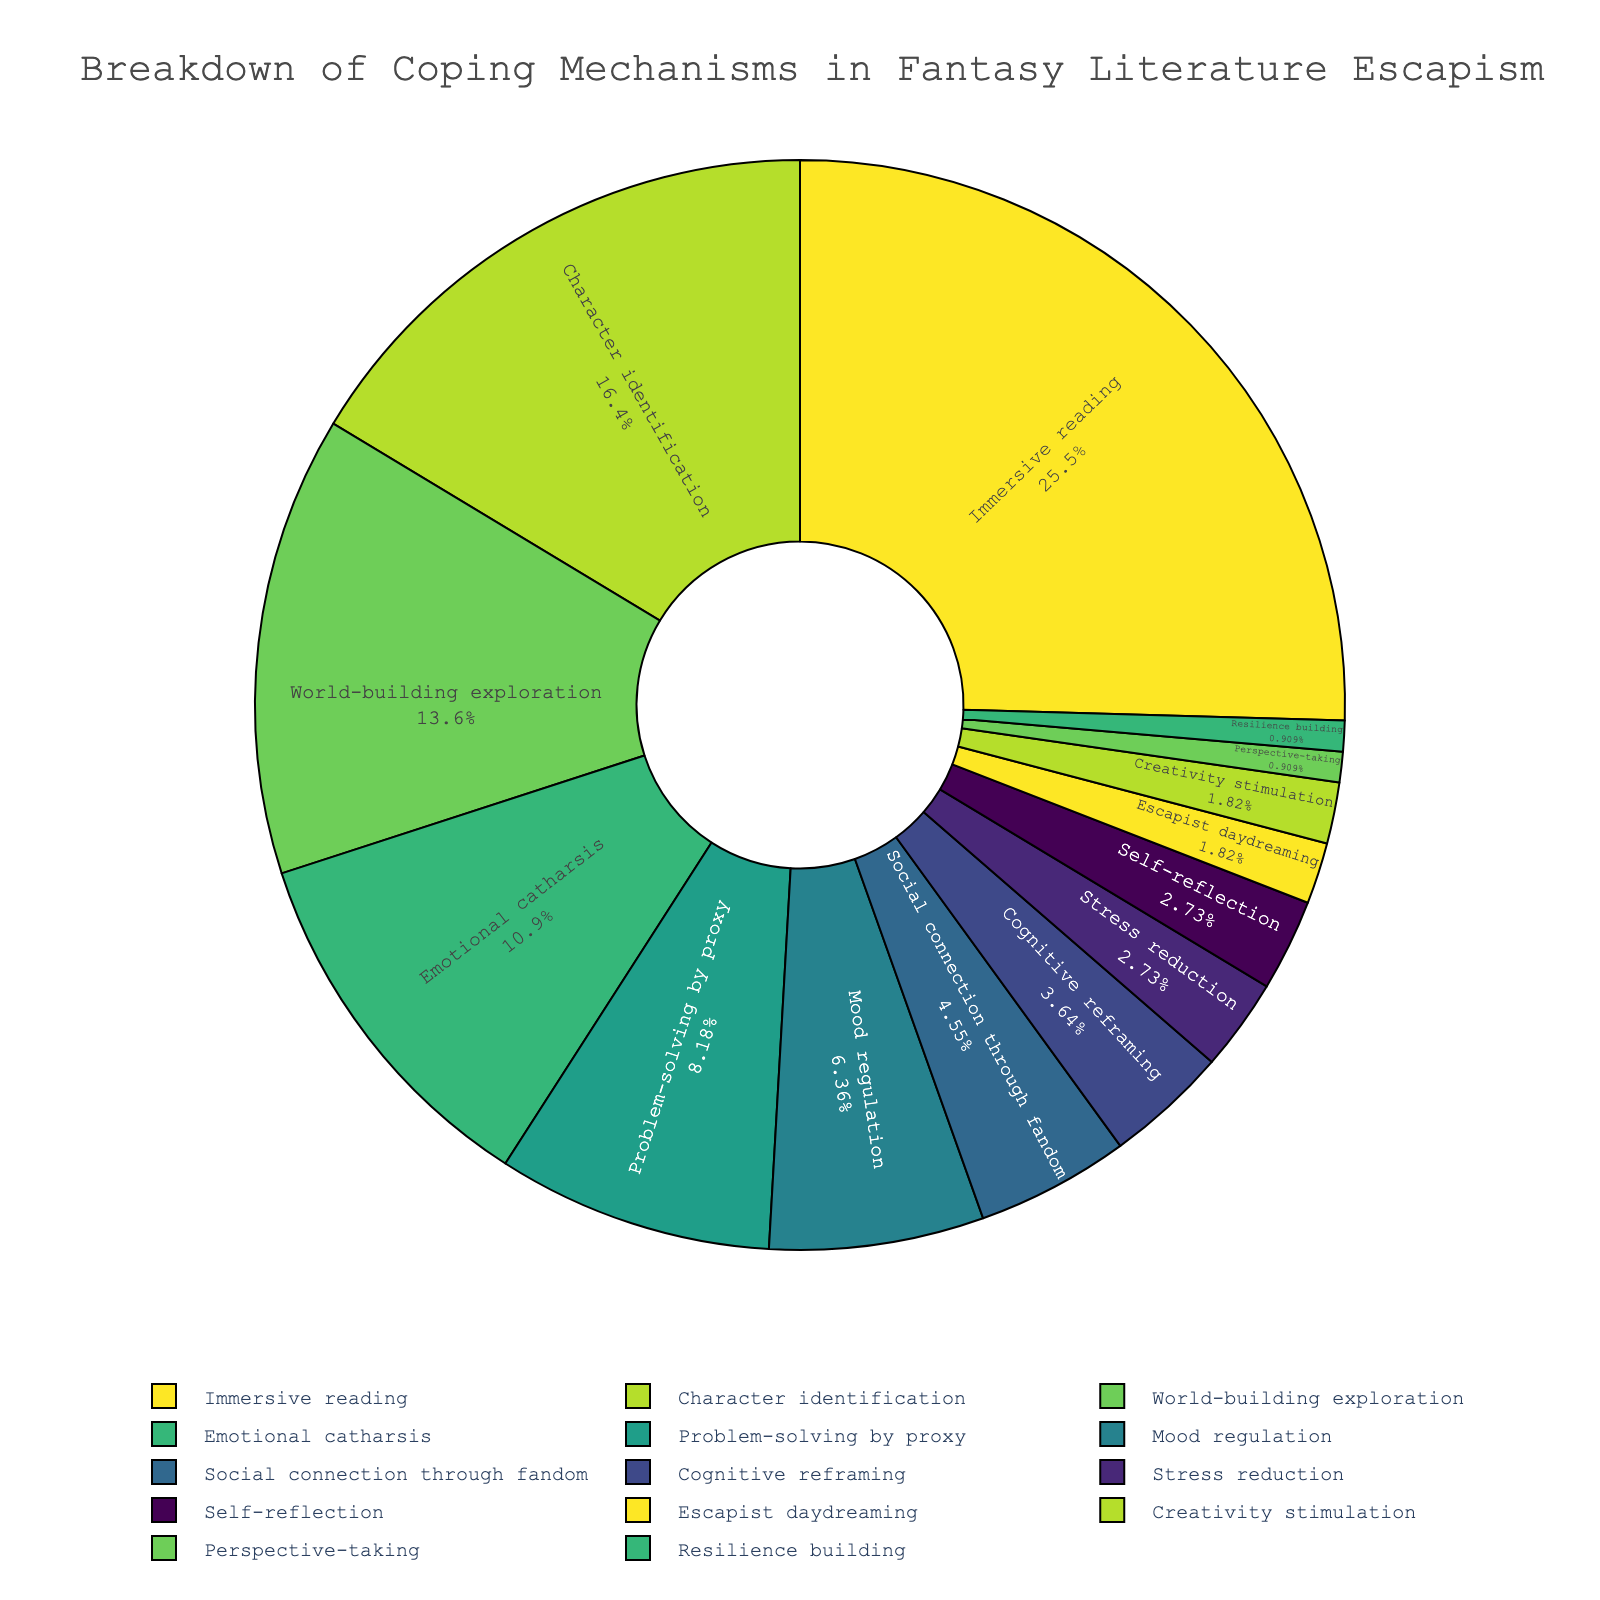Which coping mechanism has the highest percentage? To find the coping mechanism with the highest percentage, look for the largest slice in the pie chart. The title and legend provide the names and corresponding percentages. The coping mechanism with the largest slice is 'Immersive reading' at 28%.
Answer: Immersive reading What is the combined percentage of 'Stress reduction' and 'Self-reflection'? Locate the slices for 'Stress reduction' (3%) and 'Self-reflection' (3%), then add their percentages. 3% + 3% = 6%.
Answer: 6% Which coping mechanism contributes the smallest percentage to the overall pie? Identify the smallest slice in the pie chart. The title and legend can help correlate the slice with its name and percentage. 'Resilience building' and 'Perspective-taking' both contribute the smallest percentage with 1%.
Answer: Resilience building and Perspective-taking How much greater is the percentage of 'Immersive reading' compared to 'Problem-solving by proxy'? Look at the percentages of 'Immersive reading' (28%) and 'Problem-solving by proxy' (9%) and subtract the latter from the former. 28% - 9% = 19%.
Answer: 19% If 'Character identification' and 'World-building exploration' are combined, what percentage would their total be? Add the percentages of 'Character identification' (18%) and 'World-building exploration' (15%). 18% + 15% = 33%.
Answer: 33% Which coping mechanisms collectively contribute less than 5% each? Identify slices that are labeled with percentages less than 5%. These are 'Social connection through fandom' (5%), 'Cognitive reframing' (4%), 'Stress reduction' (3%), 'Self-reflection' (3%), 'Escapist daydreaming' (2%), 'Creativity stimulation' (2%), 'Perspective-taking' (1%), and 'Resilience building' (1%).
Answer: Social connection through fandom, Cognitive reframing, Stress reduction, Self-reflection, Escapist daydreaming, Creativity stimulation, Perspective-taking, Resilience building What visual representation indicates the second most employed coping mechanism? The second largest slice in terms of size, which is also confirmed by checking the legend and percentage, belongs to 'Character identification' with 18%. The color corresponding to this slice can be confirmed by looking at its representative portion in the pie chart.
Answer: Character identification How does 'Mood regulation' compare to 'World-building exploration' in percentage? Locate 'Mood regulation' (7%) and 'World-building exploration' (15%) on the chart and compare their sizes. 'World-building exploration' has a higher percentage. 15% is greater than 7%.
Answer: World-building exploration is greater What is the total percentage contribution of the top three coping mechanisms? Identify the top three mechanisms by looking at larger slices and summing their percentages: 'Immersive reading' (28%), 'Character identification' (18%), and 'World-building exploration' (15%). 28% + 18% + 15% = 61%.
Answer: 61% If we exclude 'Immersive reading', what is the percentage of all remaining coping mechanisms? Subtract the percentage of 'Immersive reading' from 100%. 100% - 28% = 72%.
Answer: 72% 